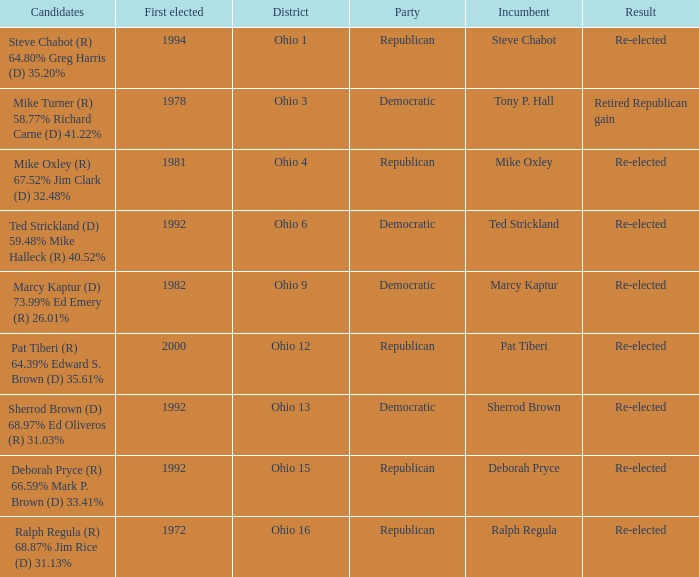Incumbent Deborah Pryce was a member of what party?  Republican. 